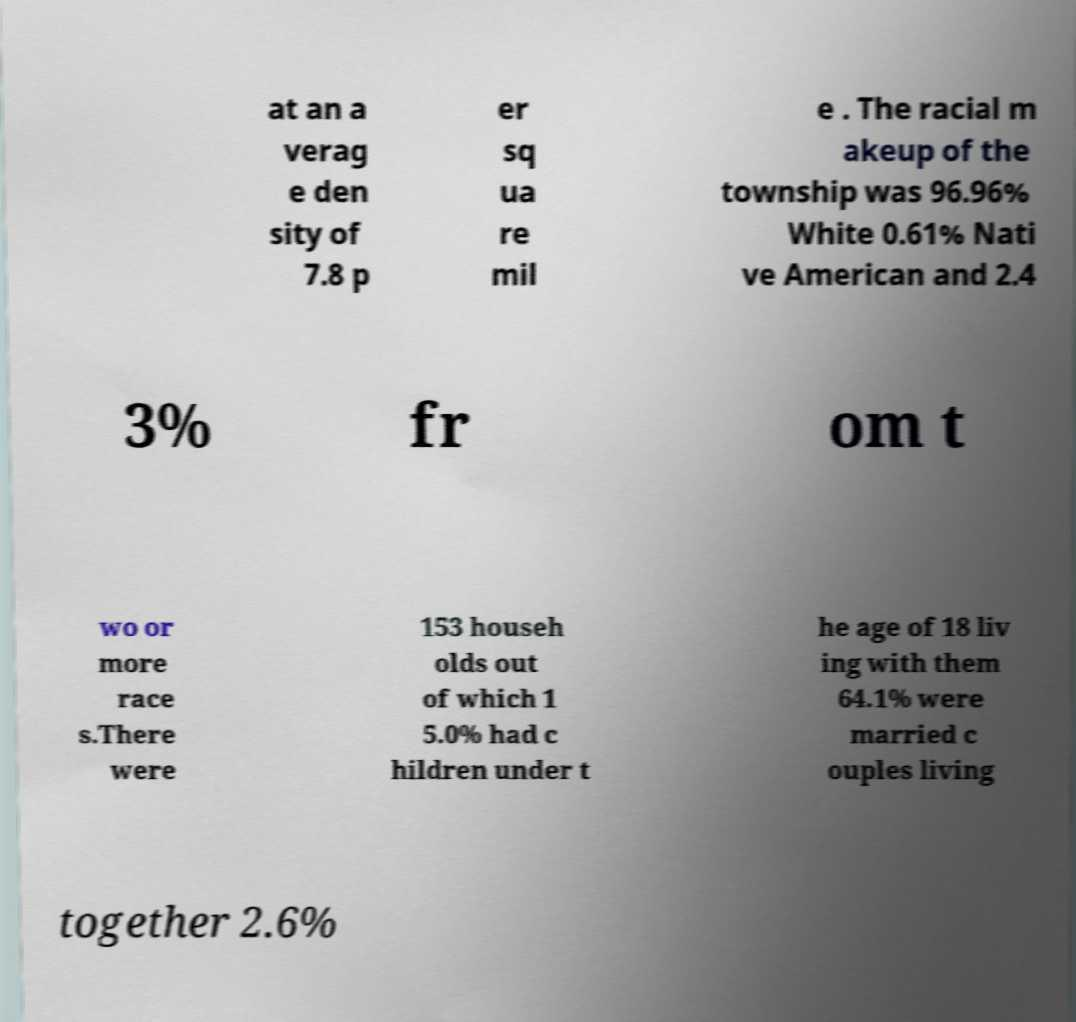Could you extract and type out the text from this image? at an a verag e den sity of 7.8 p er sq ua re mil e . The racial m akeup of the township was 96.96% White 0.61% Nati ve American and 2.4 3% fr om t wo or more race s.There were 153 househ olds out of which 1 5.0% had c hildren under t he age of 18 liv ing with them 64.1% were married c ouples living together 2.6% 